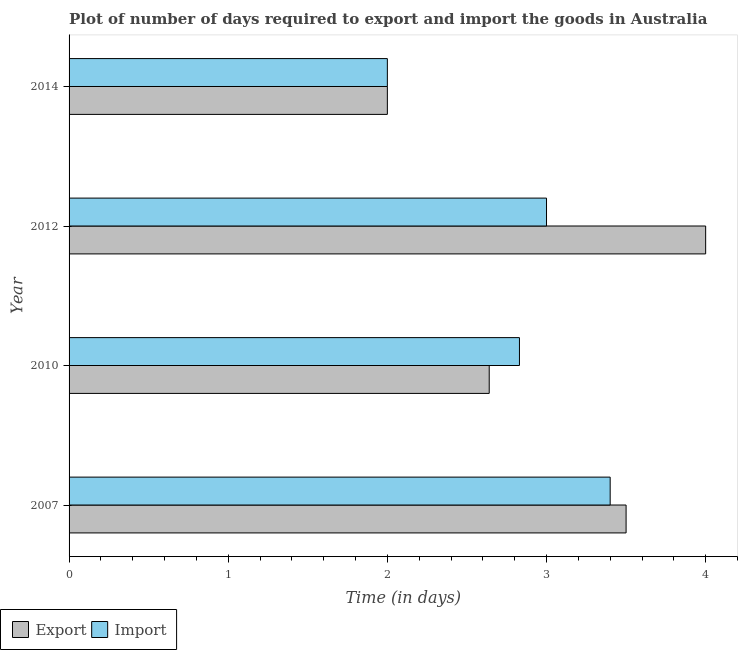How many different coloured bars are there?
Offer a terse response. 2. Are the number of bars per tick equal to the number of legend labels?
Your answer should be very brief. Yes. Are the number of bars on each tick of the Y-axis equal?
Keep it short and to the point. Yes. How many bars are there on the 1st tick from the top?
Provide a succinct answer. 2. What is the label of the 4th group of bars from the top?
Make the answer very short. 2007. What is the time required to export in 2010?
Your response must be concise. 2.64. In which year was the time required to import minimum?
Offer a very short reply. 2014. What is the total time required to import in the graph?
Your answer should be compact. 11.23. What is the difference between the time required to export in 2012 and that in 2014?
Offer a very short reply. 2. What is the difference between the time required to import in 2010 and the time required to export in 2007?
Give a very brief answer. -0.67. What is the average time required to export per year?
Your answer should be compact. 3.04. In the year 2012, what is the difference between the time required to import and time required to export?
Your response must be concise. -1. In how many years, is the time required to export greater than 0.6000000000000001 days?
Your answer should be compact. 4. What is the ratio of the time required to import in 2007 to that in 2014?
Offer a very short reply. 1.7. What is the difference between the highest and the second highest time required to import?
Your response must be concise. 0.4. In how many years, is the time required to import greater than the average time required to import taken over all years?
Offer a terse response. 3. Is the sum of the time required to import in 2010 and 2014 greater than the maximum time required to export across all years?
Ensure brevity in your answer.  Yes. What does the 1st bar from the top in 2014 represents?
Give a very brief answer. Import. What does the 2nd bar from the bottom in 2007 represents?
Provide a short and direct response. Import. How many bars are there?
Keep it short and to the point. 8. How many years are there in the graph?
Provide a succinct answer. 4. What is the difference between two consecutive major ticks on the X-axis?
Your answer should be very brief. 1. Are the values on the major ticks of X-axis written in scientific E-notation?
Ensure brevity in your answer.  No. Does the graph contain grids?
Offer a terse response. No. Where does the legend appear in the graph?
Your answer should be compact. Bottom left. How are the legend labels stacked?
Offer a terse response. Horizontal. What is the title of the graph?
Your response must be concise. Plot of number of days required to export and import the goods in Australia. What is the label or title of the X-axis?
Offer a terse response. Time (in days). What is the label or title of the Y-axis?
Make the answer very short. Year. What is the Time (in days) in Export in 2010?
Offer a very short reply. 2.64. What is the Time (in days) in Import in 2010?
Give a very brief answer. 2.83. What is the Time (in days) in Export in 2014?
Your answer should be compact. 2. Across all years, what is the minimum Time (in days) of Export?
Your response must be concise. 2. What is the total Time (in days) of Export in the graph?
Your answer should be compact. 12.14. What is the total Time (in days) in Import in the graph?
Give a very brief answer. 11.23. What is the difference between the Time (in days) of Export in 2007 and that in 2010?
Give a very brief answer. 0.86. What is the difference between the Time (in days) of Import in 2007 and that in 2010?
Ensure brevity in your answer.  0.57. What is the difference between the Time (in days) in Import in 2007 and that in 2012?
Keep it short and to the point. 0.4. What is the difference between the Time (in days) in Import in 2007 and that in 2014?
Provide a short and direct response. 1.4. What is the difference between the Time (in days) of Export in 2010 and that in 2012?
Make the answer very short. -1.36. What is the difference between the Time (in days) in Import in 2010 and that in 2012?
Provide a succinct answer. -0.17. What is the difference between the Time (in days) in Export in 2010 and that in 2014?
Your response must be concise. 0.64. What is the difference between the Time (in days) of Import in 2010 and that in 2014?
Your response must be concise. 0.83. What is the difference between the Time (in days) of Import in 2012 and that in 2014?
Give a very brief answer. 1. What is the difference between the Time (in days) of Export in 2007 and the Time (in days) of Import in 2010?
Ensure brevity in your answer.  0.67. What is the difference between the Time (in days) of Export in 2007 and the Time (in days) of Import in 2014?
Keep it short and to the point. 1.5. What is the difference between the Time (in days) in Export in 2010 and the Time (in days) in Import in 2012?
Provide a short and direct response. -0.36. What is the difference between the Time (in days) in Export in 2010 and the Time (in days) in Import in 2014?
Your answer should be very brief. 0.64. What is the difference between the Time (in days) of Export in 2012 and the Time (in days) of Import in 2014?
Provide a short and direct response. 2. What is the average Time (in days) in Export per year?
Provide a succinct answer. 3.04. What is the average Time (in days) in Import per year?
Offer a terse response. 2.81. In the year 2010, what is the difference between the Time (in days) of Export and Time (in days) of Import?
Your answer should be compact. -0.19. In the year 2014, what is the difference between the Time (in days) of Export and Time (in days) of Import?
Ensure brevity in your answer.  0. What is the ratio of the Time (in days) of Export in 2007 to that in 2010?
Ensure brevity in your answer.  1.33. What is the ratio of the Time (in days) in Import in 2007 to that in 2010?
Give a very brief answer. 1.2. What is the ratio of the Time (in days) of Export in 2007 to that in 2012?
Give a very brief answer. 0.88. What is the ratio of the Time (in days) in Import in 2007 to that in 2012?
Offer a terse response. 1.13. What is the ratio of the Time (in days) in Export in 2007 to that in 2014?
Your answer should be compact. 1.75. What is the ratio of the Time (in days) in Export in 2010 to that in 2012?
Keep it short and to the point. 0.66. What is the ratio of the Time (in days) in Import in 2010 to that in 2012?
Offer a very short reply. 0.94. What is the ratio of the Time (in days) of Export in 2010 to that in 2014?
Your response must be concise. 1.32. What is the ratio of the Time (in days) in Import in 2010 to that in 2014?
Your answer should be very brief. 1.42. What is the difference between the highest and the lowest Time (in days) of Import?
Your answer should be very brief. 1.4. 